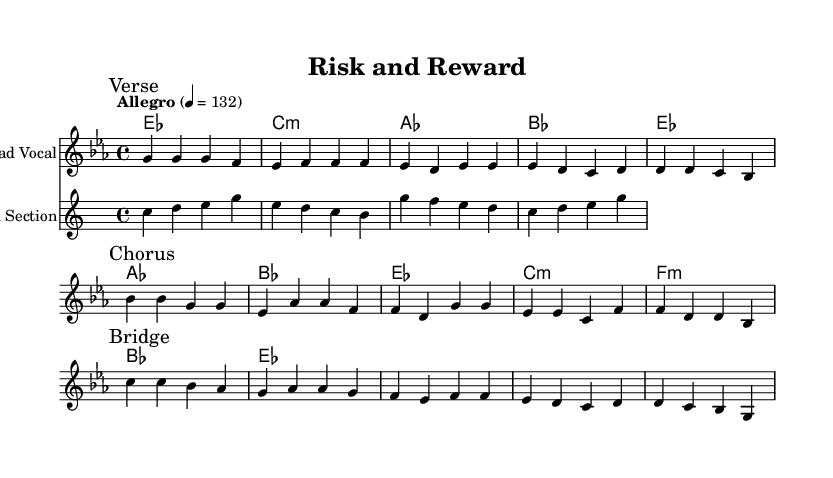What is the key signature of this music? The music is in E-flat major, which is indicated by the presence of three flats (B-flat, E-flat, and A-flat) in the key signature.
Answer: E-flat major What is the time signature of this piece? The time signature is shown at the beginning of the score with the "4/4" notation, indicating that there are four beats in each measure.
Answer: 4/4 What is the tempo marking of the piece? The tempo marking "Allegro" and "4 = 132" indicate a lively tempo of 132 beats per minute.
Answer: Allegro, 132 How many measures are in the verse section? The verse section contains four measures, as indicated by the grouping of the notes before the first break.
Answer: Four measures What is the primary theme of the chorus lyrics? The chorus lyrics emphasize taking action and seizing opportunities, suggesting that fortune favors those who are bold.
Answer: Seize the moment Which musical section follows the verse? The score indicates that the "Chorus" follows the "Verse," as marked by the respective titles in the sheet music.
Answer: Chorus What instruments are featured in this composition? The composition features a lead vocal and a horn section, as indicated by their respective staff headers in the score.
Answer: Lead Vocal, Horn Section 